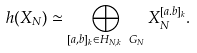<formula> <loc_0><loc_0><loc_500><loc_500>h ( X _ { N } ) \simeq \bigoplus _ { [ a , b ] _ { k } \in H _ { N , k } \ G _ { N } } X _ { N } ^ { [ a . b ] _ { k } } .</formula> 